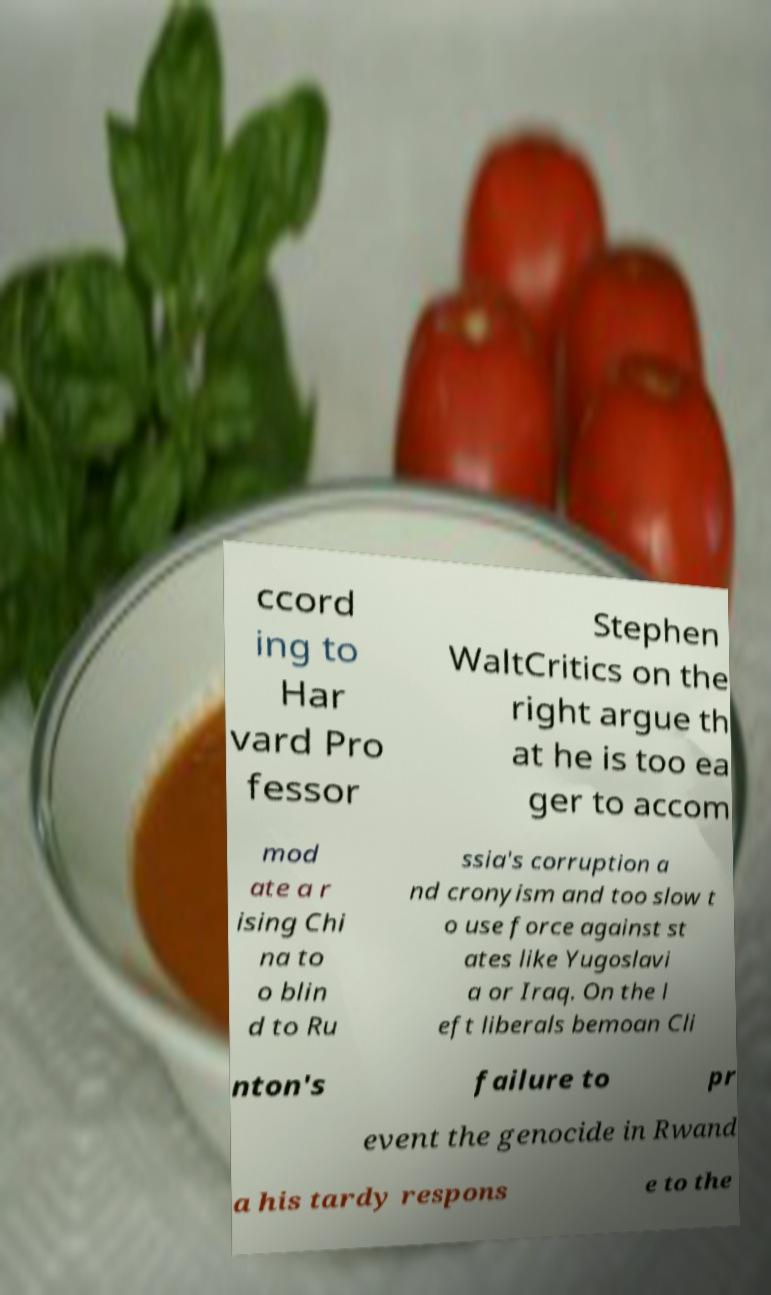Could you extract and type out the text from this image? ccord ing to Har vard Pro fessor Stephen WaltCritics on the right argue th at he is too ea ger to accom mod ate a r ising Chi na to o blin d to Ru ssia's corruption a nd cronyism and too slow t o use force against st ates like Yugoslavi a or Iraq. On the l eft liberals bemoan Cli nton's failure to pr event the genocide in Rwand a his tardy respons e to the 